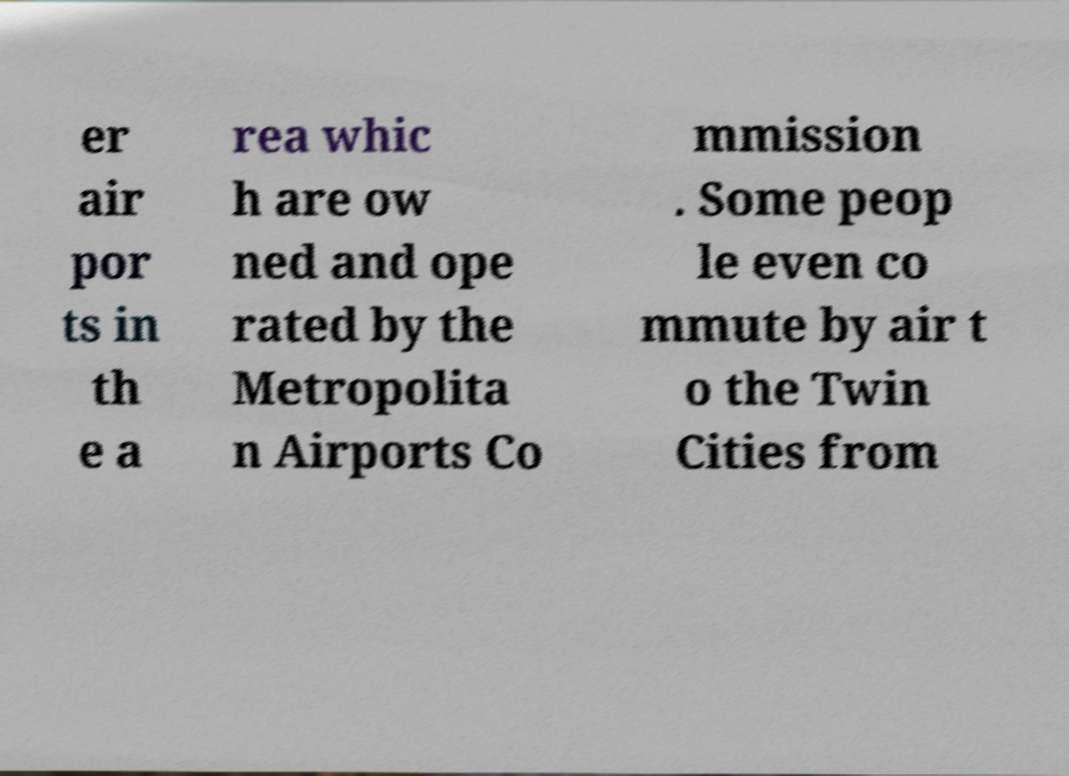There's text embedded in this image that I need extracted. Can you transcribe it verbatim? er air por ts in th e a rea whic h are ow ned and ope rated by the Metropolita n Airports Co mmission . Some peop le even co mmute by air t o the Twin Cities from 